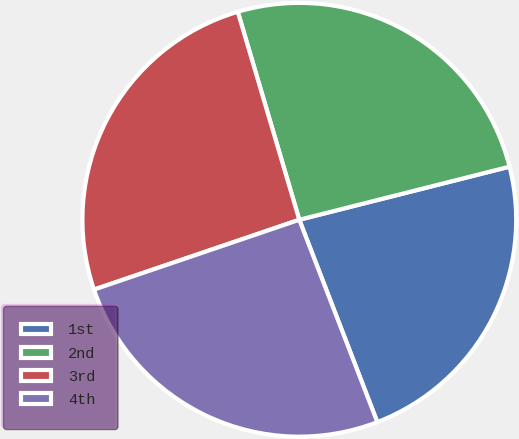<chart> <loc_0><loc_0><loc_500><loc_500><pie_chart><fcel>1st<fcel>2nd<fcel>3rd<fcel>4th<nl><fcel>23.08%<fcel>25.64%<fcel>25.64%<fcel>25.64%<nl></chart> 